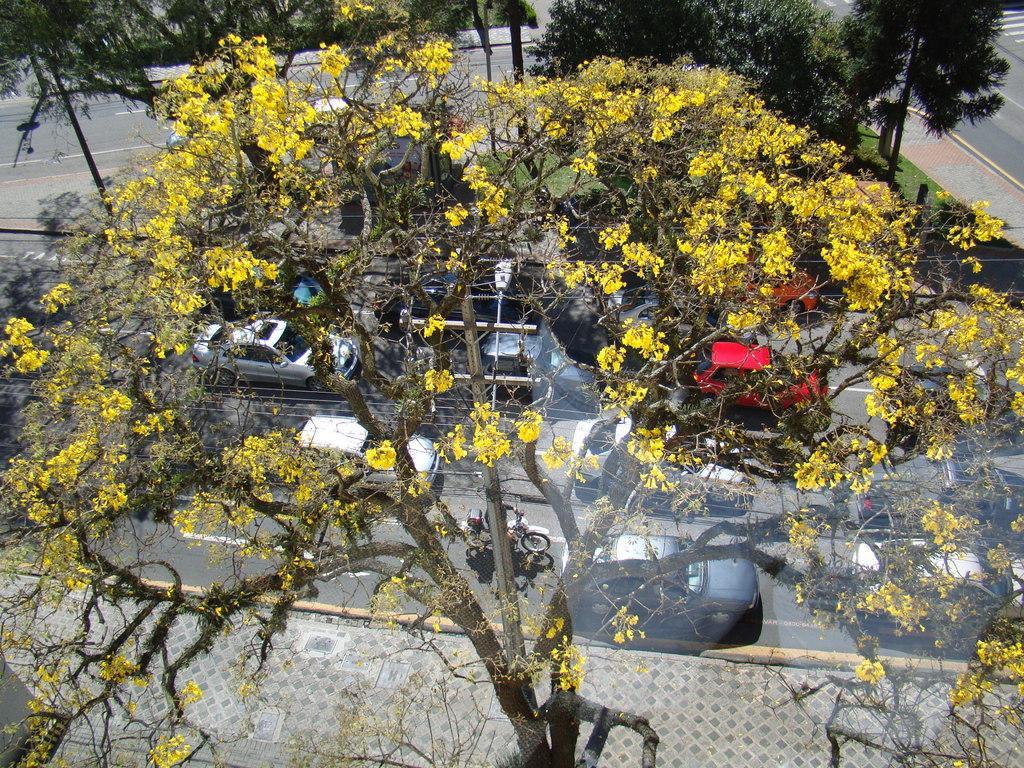In one or two sentences, can you explain what this image depicts? In this image we can see a few vehicle on the road, trees and a pavement. 